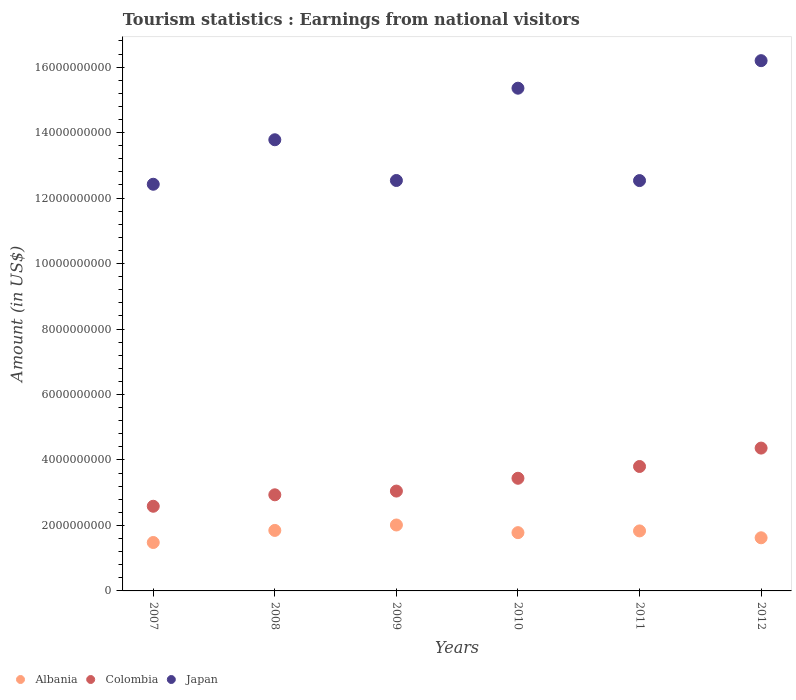What is the earnings from national visitors in Albania in 2008?
Ensure brevity in your answer.  1.85e+09. Across all years, what is the maximum earnings from national visitors in Japan?
Provide a succinct answer. 1.62e+1. Across all years, what is the minimum earnings from national visitors in Colombia?
Ensure brevity in your answer.  2.59e+09. In which year was the earnings from national visitors in Colombia maximum?
Your response must be concise. 2012. What is the total earnings from national visitors in Japan in the graph?
Ensure brevity in your answer.  8.28e+1. What is the difference between the earnings from national visitors in Japan in 2008 and that in 2010?
Your answer should be compact. -1.58e+09. What is the difference between the earnings from national visitors in Colombia in 2011 and the earnings from national visitors in Albania in 2008?
Provide a succinct answer. 1.95e+09. What is the average earnings from national visitors in Japan per year?
Give a very brief answer. 1.38e+1. In the year 2010, what is the difference between the earnings from national visitors in Albania and earnings from national visitors in Colombia?
Make the answer very short. -1.66e+09. In how many years, is the earnings from national visitors in Colombia greater than 1600000000 US$?
Provide a short and direct response. 6. What is the ratio of the earnings from national visitors in Albania in 2007 to that in 2012?
Offer a terse response. 0.91. Is the earnings from national visitors in Albania in 2008 less than that in 2011?
Your answer should be very brief. No. Is the difference between the earnings from national visitors in Albania in 2008 and 2011 greater than the difference between the earnings from national visitors in Colombia in 2008 and 2011?
Offer a terse response. Yes. What is the difference between the highest and the second highest earnings from national visitors in Colombia?
Make the answer very short. 5.62e+08. What is the difference between the highest and the lowest earnings from national visitors in Albania?
Provide a short and direct response. 5.35e+08. In how many years, is the earnings from national visitors in Colombia greater than the average earnings from national visitors in Colombia taken over all years?
Offer a very short reply. 3. Is the sum of the earnings from national visitors in Albania in 2010 and 2012 greater than the maximum earnings from national visitors in Colombia across all years?
Ensure brevity in your answer.  No. Is it the case that in every year, the sum of the earnings from national visitors in Japan and earnings from national visitors in Albania  is greater than the earnings from national visitors in Colombia?
Your response must be concise. Yes. How many dotlines are there?
Give a very brief answer. 3. How many years are there in the graph?
Make the answer very short. 6. Are the values on the major ticks of Y-axis written in scientific E-notation?
Keep it short and to the point. No. Does the graph contain grids?
Offer a terse response. No. How are the legend labels stacked?
Provide a succinct answer. Horizontal. What is the title of the graph?
Provide a succinct answer. Tourism statistics : Earnings from national visitors. What is the label or title of the Y-axis?
Make the answer very short. Amount (in US$). What is the Amount (in US$) of Albania in 2007?
Your response must be concise. 1.48e+09. What is the Amount (in US$) in Colombia in 2007?
Make the answer very short. 2.59e+09. What is the Amount (in US$) of Japan in 2007?
Give a very brief answer. 1.24e+1. What is the Amount (in US$) of Albania in 2008?
Your response must be concise. 1.85e+09. What is the Amount (in US$) of Colombia in 2008?
Your response must be concise. 2.94e+09. What is the Amount (in US$) of Japan in 2008?
Make the answer very short. 1.38e+1. What is the Amount (in US$) of Albania in 2009?
Ensure brevity in your answer.  2.01e+09. What is the Amount (in US$) in Colombia in 2009?
Offer a terse response. 3.05e+09. What is the Amount (in US$) of Japan in 2009?
Offer a very short reply. 1.25e+1. What is the Amount (in US$) of Albania in 2010?
Your answer should be very brief. 1.78e+09. What is the Amount (in US$) in Colombia in 2010?
Provide a short and direct response. 3.44e+09. What is the Amount (in US$) of Japan in 2010?
Offer a very short reply. 1.54e+1. What is the Amount (in US$) of Albania in 2011?
Provide a succinct answer. 1.83e+09. What is the Amount (in US$) in Colombia in 2011?
Offer a terse response. 3.80e+09. What is the Amount (in US$) in Japan in 2011?
Your answer should be very brief. 1.25e+1. What is the Amount (in US$) in Albania in 2012?
Offer a terse response. 1.62e+09. What is the Amount (in US$) in Colombia in 2012?
Provide a short and direct response. 4.36e+09. What is the Amount (in US$) of Japan in 2012?
Your answer should be very brief. 1.62e+1. Across all years, what is the maximum Amount (in US$) in Albania?
Offer a very short reply. 2.01e+09. Across all years, what is the maximum Amount (in US$) in Colombia?
Your answer should be compact. 4.36e+09. Across all years, what is the maximum Amount (in US$) of Japan?
Offer a very short reply. 1.62e+1. Across all years, what is the minimum Amount (in US$) of Albania?
Offer a very short reply. 1.48e+09. Across all years, what is the minimum Amount (in US$) of Colombia?
Keep it short and to the point. 2.59e+09. Across all years, what is the minimum Amount (in US$) of Japan?
Keep it short and to the point. 1.24e+1. What is the total Amount (in US$) in Albania in the graph?
Keep it short and to the point. 1.06e+1. What is the total Amount (in US$) in Colombia in the graph?
Provide a short and direct response. 2.02e+1. What is the total Amount (in US$) in Japan in the graph?
Keep it short and to the point. 8.28e+1. What is the difference between the Amount (in US$) of Albania in 2007 and that in 2008?
Give a very brief answer. -3.69e+08. What is the difference between the Amount (in US$) in Colombia in 2007 and that in 2008?
Offer a very short reply. -3.50e+08. What is the difference between the Amount (in US$) of Japan in 2007 and that in 2008?
Offer a very short reply. -1.36e+09. What is the difference between the Amount (in US$) of Albania in 2007 and that in 2009?
Offer a terse response. -5.35e+08. What is the difference between the Amount (in US$) of Colombia in 2007 and that in 2009?
Make the answer very short. -4.64e+08. What is the difference between the Amount (in US$) of Japan in 2007 and that in 2009?
Offer a terse response. -1.15e+08. What is the difference between the Amount (in US$) in Albania in 2007 and that in 2010?
Provide a succinct answer. -3.01e+08. What is the difference between the Amount (in US$) in Colombia in 2007 and that in 2010?
Your answer should be very brief. -8.55e+08. What is the difference between the Amount (in US$) of Japan in 2007 and that in 2010?
Give a very brief answer. -2.93e+09. What is the difference between the Amount (in US$) of Albania in 2007 and that in 2011?
Offer a very short reply. -3.54e+08. What is the difference between the Amount (in US$) in Colombia in 2007 and that in 2011?
Keep it short and to the point. -1.22e+09. What is the difference between the Amount (in US$) of Japan in 2007 and that in 2011?
Keep it short and to the point. -1.12e+08. What is the difference between the Amount (in US$) in Albania in 2007 and that in 2012?
Offer a very short reply. -1.44e+08. What is the difference between the Amount (in US$) in Colombia in 2007 and that in 2012?
Offer a very short reply. -1.78e+09. What is the difference between the Amount (in US$) of Japan in 2007 and that in 2012?
Keep it short and to the point. -3.78e+09. What is the difference between the Amount (in US$) of Albania in 2008 and that in 2009?
Ensure brevity in your answer.  -1.66e+08. What is the difference between the Amount (in US$) of Colombia in 2008 and that in 2009?
Offer a terse response. -1.14e+08. What is the difference between the Amount (in US$) in Japan in 2008 and that in 2009?
Your response must be concise. 1.24e+09. What is the difference between the Amount (in US$) of Albania in 2008 and that in 2010?
Make the answer very short. 6.80e+07. What is the difference between the Amount (in US$) in Colombia in 2008 and that in 2010?
Ensure brevity in your answer.  -5.05e+08. What is the difference between the Amount (in US$) of Japan in 2008 and that in 2010?
Provide a succinct answer. -1.58e+09. What is the difference between the Amount (in US$) in Albania in 2008 and that in 2011?
Make the answer very short. 1.50e+07. What is the difference between the Amount (in US$) in Colombia in 2008 and that in 2011?
Your response must be concise. -8.65e+08. What is the difference between the Amount (in US$) of Japan in 2008 and that in 2011?
Offer a very short reply. 1.25e+09. What is the difference between the Amount (in US$) in Albania in 2008 and that in 2012?
Make the answer very short. 2.25e+08. What is the difference between the Amount (in US$) in Colombia in 2008 and that in 2012?
Make the answer very short. -1.43e+09. What is the difference between the Amount (in US$) in Japan in 2008 and that in 2012?
Offer a terse response. -2.42e+09. What is the difference between the Amount (in US$) in Albania in 2009 and that in 2010?
Your response must be concise. 2.34e+08. What is the difference between the Amount (in US$) of Colombia in 2009 and that in 2010?
Make the answer very short. -3.91e+08. What is the difference between the Amount (in US$) in Japan in 2009 and that in 2010?
Your response must be concise. -2.82e+09. What is the difference between the Amount (in US$) in Albania in 2009 and that in 2011?
Ensure brevity in your answer.  1.81e+08. What is the difference between the Amount (in US$) in Colombia in 2009 and that in 2011?
Keep it short and to the point. -7.51e+08. What is the difference between the Amount (in US$) of Albania in 2009 and that in 2012?
Your answer should be very brief. 3.91e+08. What is the difference between the Amount (in US$) in Colombia in 2009 and that in 2012?
Make the answer very short. -1.31e+09. What is the difference between the Amount (in US$) of Japan in 2009 and that in 2012?
Keep it short and to the point. -3.66e+09. What is the difference between the Amount (in US$) of Albania in 2010 and that in 2011?
Offer a terse response. -5.30e+07. What is the difference between the Amount (in US$) in Colombia in 2010 and that in 2011?
Provide a succinct answer. -3.60e+08. What is the difference between the Amount (in US$) of Japan in 2010 and that in 2011?
Your answer should be compact. 2.82e+09. What is the difference between the Amount (in US$) in Albania in 2010 and that in 2012?
Provide a succinct answer. 1.57e+08. What is the difference between the Amount (in US$) in Colombia in 2010 and that in 2012?
Offer a very short reply. -9.22e+08. What is the difference between the Amount (in US$) of Japan in 2010 and that in 2012?
Keep it short and to the point. -8.41e+08. What is the difference between the Amount (in US$) of Albania in 2011 and that in 2012?
Keep it short and to the point. 2.10e+08. What is the difference between the Amount (in US$) in Colombia in 2011 and that in 2012?
Make the answer very short. -5.62e+08. What is the difference between the Amount (in US$) of Japan in 2011 and that in 2012?
Offer a terse response. -3.66e+09. What is the difference between the Amount (in US$) in Albania in 2007 and the Amount (in US$) in Colombia in 2008?
Give a very brief answer. -1.46e+09. What is the difference between the Amount (in US$) of Albania in 2007 and the Amount (in US$) of Japan in 2008?
Your response must be concise. -1.23e+1. What is the difference between the Amount (in US$) of Colombia in 2007 and the Amount (in US$) of Japan in 2008?
Your answer should be very brief. -1.12e+1. What is the difference between the Amount (in US$) in Albania in 2007 and the Amount (in US$) in Colombia in 2009?
Provide a short and direct response. -1.57e+09. What is the difference between the Amount (in US$) of Albania in 2007 and the Amount (in US$) of Japan in 2009?
Make the answer very short. -1.11e+1. What is the difference between the Amount (in US$) in Colombia in 2007 and the Amount (in US$) in Japan in 2009?
Your answer should be very brief. -9.95e+09. What is the difference between the Amount (in US$) of Albania in 2007 and the Amount (in US$) of Colombia in 2010?
Keep it short and to the point. -1.96e+09. What is the difference between the Amount (in US$) in Albania in 2007 and the Amount (in US$) in Japan in 2010?
Make the answer very short. -1.39e+1. What is the difference between the Amount (in US$) in Colombia in 2007 and the Amount (in US$) in Japan in 2010?
Your answer should be very brief. -1.28e+1. What is the difference between the Amount (in US$) in Albania in 2007 and the Amount (in US$) in Colombia in 2011?
Give a very brief answer. -2.32e+09. What is the difference between the Amount (in US$) in Albania in 2007 and the Amount (in US$) in Japan in 2011?
Offer a terse response. -1.11e+1. What is the difference between the Amount (in US$) of Colombia in 2007 and the Amount (in US$) of Japan in 2011?
Offer a terse response. -9.95e+09. What is the difference between the Amount (in US$) in Albania in 2007 and the Amount (in US$) in Colombia in 2012?
Offer a very short reply. -2.88e+09. What is the difference between the Amount (in US$) of Albania in 2007 and the Amount (in US$) of Japan in 2012?
Your response must be concise. -1.47e+1. What is the difference between the Amount (in US$) of Colombia in 2007 and the Amount (in US$) of Japan in 2012?
Provide a succinct answer. -1.36e+1. What is the difference between the Amount (in US$) of Albania in 2008 and the Amount (in US$) of Colombia in 2009?
Provide a succinct answer. -1.20e+09. What is the difference between the Amount (in US$) in Albania in 2008 and the Amount (in US$) in Japan in 2009?
Offer a very short reply. -1.07e+1. What is the difference between the Amount (in US$) of Colombia in 2008 and the Amount (in US$) of Japan in 2009?
Offer a terse response. -9.60e+09. What is the difference between the Amount (in US$) in Albania in 2008 and the Amount (in US$) in Colombia in 2010?
Provide a succinct answer. -1.59e+09. What is the difference between the Amount (in US$) of Albania in 2008 and the Amount (in US$) of Japan in 2010?
Offer a very short reply. -1.35e+1. What is the difference between the Amount (in US$) of Colombia in 2008 and the Amount (in US$) of Japan in 2010?
Your answer should be compact. -1.24e+1. What is the difference between the Amount (in US$) in Albania in 2008 and the Amount (in US$) in Colombia in 2011?
Ensure brevity in your answer.  -1.95e+09. What is the difference between the Amount (in US$) of Albania in 2008 and the Amount (in US$) of Japan in 2011?
Your answer should be very brief. -1.07e+1. What is the difference between the Amount (in US$) in Colombia in 2008 and the Amount (in US$) in Japan in 2011?
Make the answer very short. -9.60e+09. What is the difference between the Amount (in US$) in Albania in 2008 and the Amount (in US$) in Colombia in 2012?
Offer a very short reply. -2.52e+09. What is the difference between the Amount (in US$) of Albania in 2008 and the Amount (in US$) of Japan in 2012?
Make the answer very short. -1.43e+1. What is the difference between the Amount (in US$) of Colombia in 2008 and the Amount (in US$) of Japan in 2012?
Make the answer very short. -1.33e+1. What is the difference between the Amount (in US$) in Albania in 2009 and the Amount (in US$) in Colombia in 2010?
Offer a very short reply. -1.43e+09. What is the difference between the Amount (in US$) of Albania in 2009 and the Amount (in US$) of Japan in 2010?
Provide a succinct answer. -1.33e+1. What is the difference between the Amount (in US$) of Colombia in 2009 and the Amount (in US$) of Japan in 2010?
Ensure brevity in your answer.  -1.23e+1. What is the difference between the Amount (in US$) of Albania in 2009 and the Amount (in US$) of Colombia in 2011?
Offer a terse response. -1.79e+09. What is the difference between the Amount (in US$) in Albania in 2009 and the Amount (in US$) in Japan in 2011?
Offer a terse response. -1.05e+1. What is the difference between the Amount (in US$) of Colombia in 2009 and the Amount (in US$) of Japan in 2011?
Provide a short and direct response. -9.48e+09. What is the difference between the Amount (in US$) in Albania in 2009 and the Amount (in US$) in Colombia in 2012?
Ensure brevity in your answer.  -2.35e+09. What is the difference between the Amount (in US$) in Albania in 2009 and the Amount (in US$) in Japan in 2012?
Offer a terse response. -1.42e+1. What is the difference between the Amount (in US$) of Colombia in 2009 and the Amount (in US$) of Japan in 2012?
Your answer should be very brief. -1.31e+1. What is the difference between the Amount (in US$) in Albania in 2010 and the Amount (in US$) in Colombia in 2011?
Provide a succinct answer. -2.02e+09. What is the difference between the Amount (in US$) in Albania in 2010 and the Amount (in US$) in Japan in 2011?
Ensure brevity in your answer.  -1.08e+1. What is the difference between the Amount (in US$) of Colombia in 2010 and the Amount (in US$) of Japan in 2011?
Give a very brief answer. -9.09e+09. What is the difference between the Amount (in US$) in Albania in 2010 and the Amount (in US$) in Colombia in 2012?
Your answer should be very brief. -2.58e+09. What is the difference between the Amount (in US$) in Albania in 2010 and the Amount (in US$) in Japan in 2012?
Ensure brevity in your answer.  -1.44e+1. What is the difference between the Amount (in US$) of Colombia in 2010 and the Amount (in US$) of Japan in 2012?
Your response must be concise. -1.28e+1. What is the difference between the Amount (in US$) in Albania in 2011 and the Amount (in US$) in Colombia in 2012?
Keep it short and to the point. -2.53e+09. What is the difference between the Amount (in US$) of Albania in 2011 and the Amount (in US$) of Japan in 2012?
Ensure brevity in your answer.  -1.44e+1. What is the difference between the Amount (in US$) in Colombia in 2011 and the Amount (in US$) in Japan in 2012?
Make the answer very short. -1.24e+1. What is the average Amount (in US$) in Albania per year?
Make the answer very short. 1.76e+09. What is the average Amount (in US$) in Colombia per year?
Your answer should be very brief. 3.36e+09. What is the average Amount (in US$) of Japan per year?
Provide a succinct answer. 1.38e+1. In the year 2007, what is the difference between the Amount (in US$) in Albania and Amount (in US$) in Colombia?
Give a very brief answer. -1.11e+09. In the year 2007, what is the difference between the Amount (in US$) in Albania and Amount (in US$) in Japan?
Offer a terse response. -1.09e+1. In the year 2007, what is the difference between the Amount (in US$) in Colombia and Amount (in US$) in Japan?
Ensure brevity in your answer.  -9.84e+09. In the year 2008, what is the difference between the Amount (in US$) in Albania and Amount (in US$) in Colombia?
Your answer should be very brief. -1.09e+09. In the year 2008, what is the difference between the Amount (in US$) of Albania and Amount (in US$) of Japan?
Keep it short and to the point. -1.19e+1. In the year 2008, what is the difference between the Amount (in US$) in Colombia and Amount (in US$) in Japan?
Your answer should be compact. -1.08e+1. In the year 2009, what is the difference between the Amount (in US$) in Albania and Amount (in US$) in Colombia?
Give a very brief answer. -1.04e+09. In the year 2009, what is the difference between the Amount (in US$) of Albania and Amount (in US$) of Japan?
Make the answer very short. -1.05e+1. In the year 2009, what is the difference between the Amount (in US$) of Colombia and Amount (in US$) of Japan?
Provide a short and direct response. -9.49e+09. In the year 2010, what is the difference between the Amount (in US$) of Albania and Amount (in US$) of Colombia?
Keep it short and to the point. -1.66e+09. In the year 2010, what is the difference between the Amount (in US$) of Albania and Amount (in US$) of Japan?
Provide a succinct answer. -1.36e+1. In the year 2010, what is the difference between the Amount (in US$) in Colombia and Amount (in US$) in Japan?
Provide a succinct answer. -1.19e+1. In the year 2011, what is the difference between the Amount (in US$) in Albania and Amount (in US$) in Colombia?
Your answer should be compact. -1.97e+09. In the year 2011, what is the difference between the Amount (in US$) in Albania and Amount (in US$) in Japan?
Your response must be concise. -1.07e+1. In the year 2011, what is the difference between the Amount (in US$) of Colombia and Amount (in US$) of Japan?
Provide a succinct answer. -8.73e+09. In the year 2012, what is the difference between the Amount (in US$) of Albania and Amount (in US$) of Colombia?
Your response must be concise. -2.74e+09. In the year 2012, what is the difference between the Amount (in US$) in Albania and Amount (in US$) in Japan?
Your response must be concise. -1.46e+1. In the year 2012, what is the difference between the Amount (in US$) of Colombia and Amount (in US$) of Japan?
Give a very brief answer. -1.18e+1. What is the ratio of the Amount (in US$) in Albania in 2007 to that in 2008?
Make the answer very short. 0.8. What is the ratio of the Amount (in US$) of Colombia in 2007 to that in 2008?
Provide a succinct answer. 0.88. What is the ratio of the Amount (in US$) in Japan in 2007 to that in 2008?
Offer a very short reply. 0.9. What is the ratio of the Amount (in US$) of Albania in 2007 to that in 2009?
Keep it short and to the point. 0.73. What is the ratio of the Amount (in US$) in Colombia in 2007 to that in 2009?
Offer a very short reply. 0.85. What is the ratio of the Amount (in US$) of Japan in 2007 to that in 2009?
Provide a succinct answer. 0.99. What is the ratio of the Amount (in US$) of Albania in 2007 to that in 2010?
Your answer should be compact. 0.83. What is the ratio of the Amount (in US$) in Colombia in 2007 to that in 2010?
Provide a short and direct response. 0.75. What is the ratio of the Amount (in US$) of Japan in 2007 to that in 2010?
Offer a terse response. 0.81. What is the ratio of the Amount (in US$) in Albania in 2007 to that in 2011?
Provide a succinct answer. 0.81. What is the ratio of the Amount (in US$) of Colombia in 2007 to that in 2011?
Give a very brief answer. 0.68. What is the ratio of the Amount (in US$) in Japan in 2007 to that in 2011?
Give a very brief answer. 0.99. What is the ratio of the Amount (in US$) in Albania in 2007 to that in 2012?
Give a very brief answer. 0.91. What is the ratio of the Amount (in US$) of Colombia in 2007 to that in 2012?
Your answer should be compact. 0.59. What is the ratio of the Amount (in US$) of Japan in 2007 to that in 2012?
Give a very brief answer. 0.77. What is the ratio of the Amount (in US$) of Albania in 2008 to that in 2009?
Ensure brevity in your answer.  0.92. What is the ratio of the Amount (in US$) in Colombia in 2008 to that in 2009?
Your answer should be very brief. 0.96. What is the ratio of the Amount (in US$) in Japan in 2008 to that in 2009?
Offer a very short reply. 1.1. What is the ratio of the Amount (in US$) of Albania in 2008 to that in 2010?
Give a very brief answer. 1.04. What is the ratio of the Amount (in US$) of Colombia in 2008 to that in 2010?
Offer a terse response. 0.85. What is the ratio of the Amount (in US$) in Japan in 2008 to that in 2010?
Give a very brief answer. 0.9. What is the ratio of the Amount (in US$) of Albania in 2008 to that in 2011?
Provide a succinct answer. 1.01. What is the ratio of the Amount (in US$) of Colombia in 2008 to that in 2011?
Provide a succinct answer. 0.77. What is the ratio of the Amount (in US$) in Japan in 2008 to that in 2011?
Provide a short and direct response. 1.1. What is the ratio of the Amount (in US$) in Albania in 2008 to that in 2012?
Offer a terse response. 1.14. What is the ratio of the Amount (in US$) of Colombia in 2008 to that in 2012?
Ensure brevity in your answer.  0.67. What is the ratio of the Amount (in US$) of Japan in 2008 to that in 2012?
Your answer should be compact. 0.85. What is the ratio of the Amount (in US$) in Albania in 2009 to that in 2010?
Your response must be concise. 1.13. What is the ratio of the Amount (in US$) of Colombia in 2009 to that in 2010?
Ensure brevity in your answer.  0.89. What is the ratio of the Amount (in US$) of Japan in 2009 to that in 2010?
Your answer should be very brief. 0.82. What is the ratio of the Amount (in US$) in Albania in 2009 to that in 2011?
Give a very brief answer. 1.1. What is the ratio of the Amount (in US$) in Colombia in 2009 to that in 2011?
Provide a short and direct response. 0.8. What is the ratio of the Amount (in US$) in Japan in 2009 to that in 2011?
Offer a terse response. 1. What is the ratio of the Amount (in US$) of Albania in 2009 to that in 2012?
Your answer should be compact. 1.24. What is the ratio of the Amount (in US$) in Colombia in 2009 to that in 2012?
Ensure brevity in your answer.  0.7. What is the ratio of the Amount (in US$) of Japan in 2009 to that in 2012?
Your response must be concise. 0.77. What is the ratio of the Amount (in US$) of Albania in 2010 to that in 2011?
Offer a very short reply. 0.97. What is the ratio of the Amount (in US$) of Colombia in 2010 to that in 2011?
Your answer should be compact. 0.91. What is the ratio of the Amount (in US$) in Japan in 2010 to that in 2011?
Offer a very short reply. 1.23. What is the ratio of the Amount (in US$) of Albania in 2010 to that in 2012?
Your answer should be compact. 1.1. What is the ratio of the Amount (in US$) in Colombia in 2010 to that in 2012?
Your answer should be compact. 0.79. What is the ratio of the Amount (in US$) of Japan in 2010 to that in 2012?
Offer a terse response. 0.95. What is the ratio of the Amount (in US$) of Albania in 2011 to that in 2012?
Make the answer very short. 1.13. What is the ratio of the Amount (in US$) of Colombia in 2011 to that in 2012?
Give a very brief answer. 0.87. What is the ratio of the Amount (in US$) of Japan in 2011 to that in 2012?
Provide a short and direct response. 0.77. What is the difference between the highest and the second highest Amount (in US$) of Albania?
Your answer should be compact. 1.66e+08. What is the difference between the highest and the second highest Amount (in US$) of Colombia?
Your response must be concise. 5.62e+08. What is the difference between the highest and the second highest Amount (in US$) of Japan?
Your answer should be compact. 8.41e+08. What is the difference between the highest and the lowest Amount (in US$) in Albania?
Give a very brief answer. 5.35e+08. What is the difference between the highest and the lowest Amount (in US$) of Colombia?
Offer a terse response. 1.78e+09. What is the difference between the highest and the lowest Amount (in US$) of Japan?
Your answer should be very brief. 3.78e+09. 